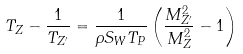<formula> <loc_0><loc_0><loc_500><loc_500>T _ { Z } - \frac { 1 } { T _ { Z ^ { \prime } } } = \frac { 1 } { \rho S _ { W } T _ { P } } \left ( \frac { M _ { Z ^ { \prime } } ^ { 2 } } { M _ { Z } ^ { 2 } } - 1 \right )</formula> 